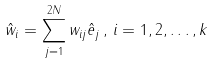Convert formula to latex. <formula><loc_0><loc_0><loc_500><loc_500>\hat { w } _ { i } = \sum _ { j = 1 } ^ { 2 N } w _ { i j } \hat { e } _ { j } \, , \, i = 1 , 2 , \dots , k</formula> 